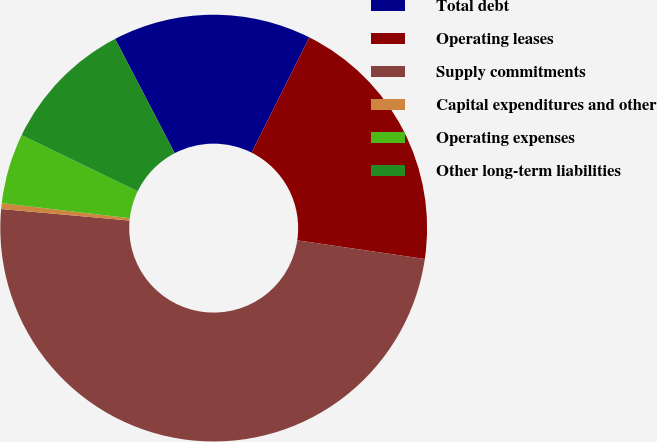Convert chart. <chart><loc_0><loc_0><loc_500><loc_500><pie_chart><fcel>Total debt<fcel>Operating leases<fcel>Supply commitments<fcel>Capital expenditures and other<fcel>Operating expenses<fcel>Other long-term liabilities<nl><fcel>15.04%<fcel>19.91%<fcel>49.11%<fcel>0.44%<fcel>5.31%<fcel>10.18%<nl></chart> 